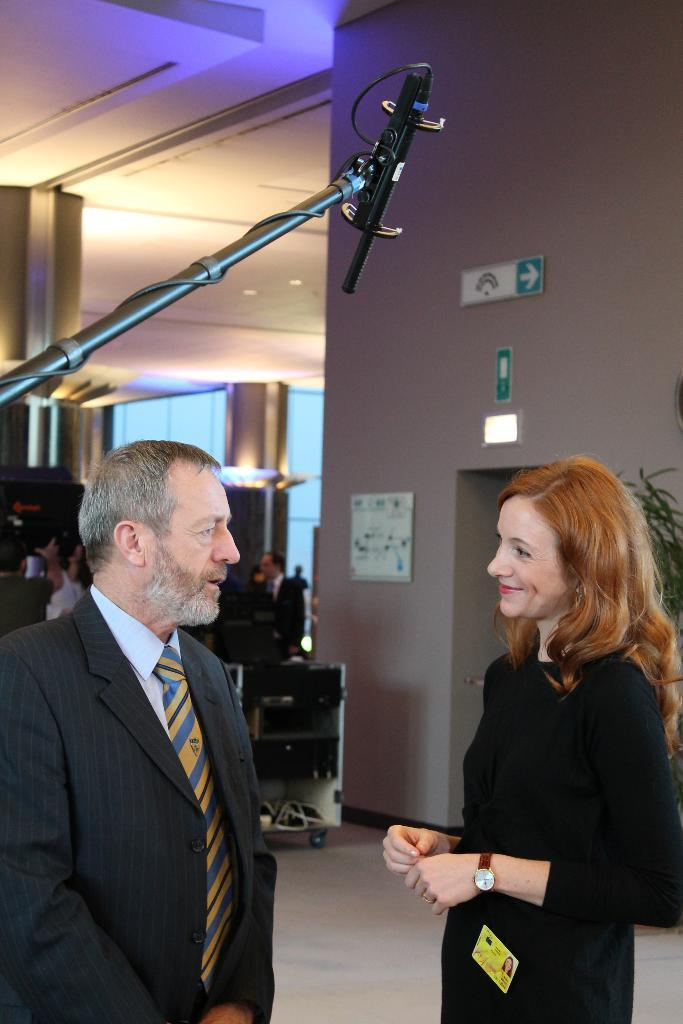What can be seen in the image involving people? There are people standing in the image. What type of informational objects are present in the image? There are sign boards and information boards in the image. What type of vegetation is present in the image? There are houseplants in the image. What type of lighting is present in the image? There are electric lights in the image. What type of structure is visible in the image? There are walls visible in the image. What type of creature is interacting with the hand in the image? There is no creature or hand present in the image. What type of recess can be seen in the image? There is no recess present in the image. 